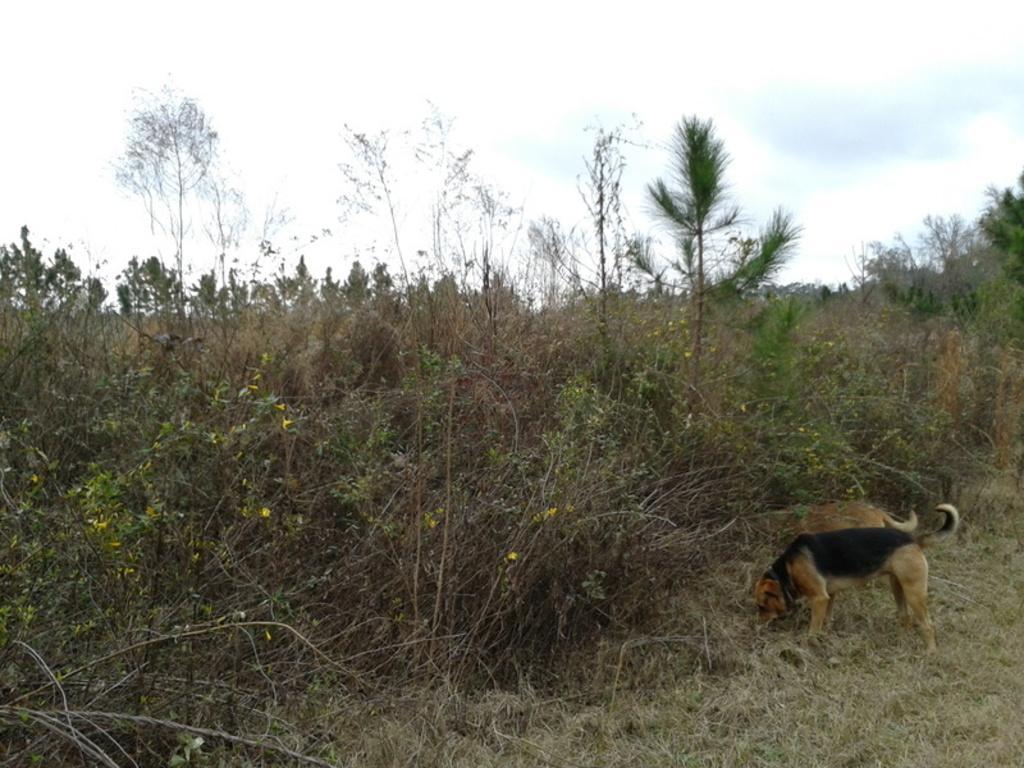Please provide a concise description of this image. in this image there are two dogs on the right side. In front of them there are plants. At the top there is the sky. At the bottom there is grass. 